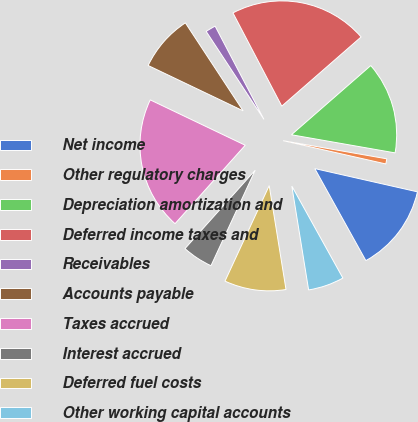Convert chart to OTSL. <chart><loc_0><loc_0><loc_500><loc_500><pie_chart><fcel>Net income<fcel>Other regulatory charges<fcel>Depreciation amortization and<fcel>Deferred income taxes and<fcel>Receivables<fcel>Accounts payable<fcel>Taxes accrued<fcel>Interest accrued<fcel>Deferred fuel costs<fcel>Other working capital accounts<nl><fcel>13.39%<fcel>0.79%<fcel>14.17%<fcel>21.26%<fcel>1.57%<fcel>8.66%<fcel>20.47%<fcel>4.72%<fcel>9.45%<fcel>5.51%<nl></chart> 